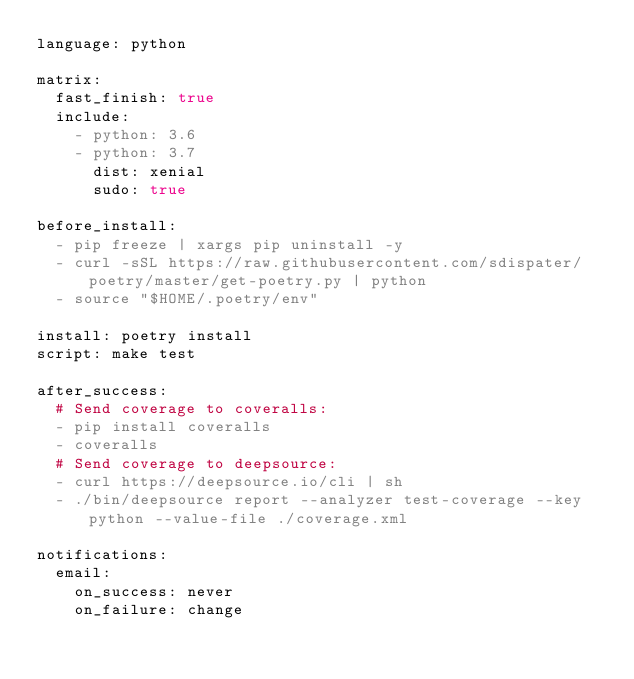<code> <loc_0><loc_0><loc_500><loc_500><_YAML_>language: python

matrix:
  fast_finish: true
  include:
    - python: 3.6
    - python: 3.7
      dist: xenial
      sudo: true

before_install:
  - pip freeze | xargs pip uninstall -y
  - curl -sSL https://raw.githubusercontent.com/sdispater/poetry/master/get-poetry.py | python
  - source "$HOME/.poetry/env"

install: poetry install
script: make test

after_success:
  # Send coverage to coveralls:
  - pip install coveralls
  - coveralls
  # Send coverage to deepsource:
  - curl https://deepsource.io/cli | sh
  - ./bin/deepsource report --analyzer test-coverage --key python --value-file ./coverage.xml

notifications:
  email:
    on_success: never
    on_failure: change
</code> 